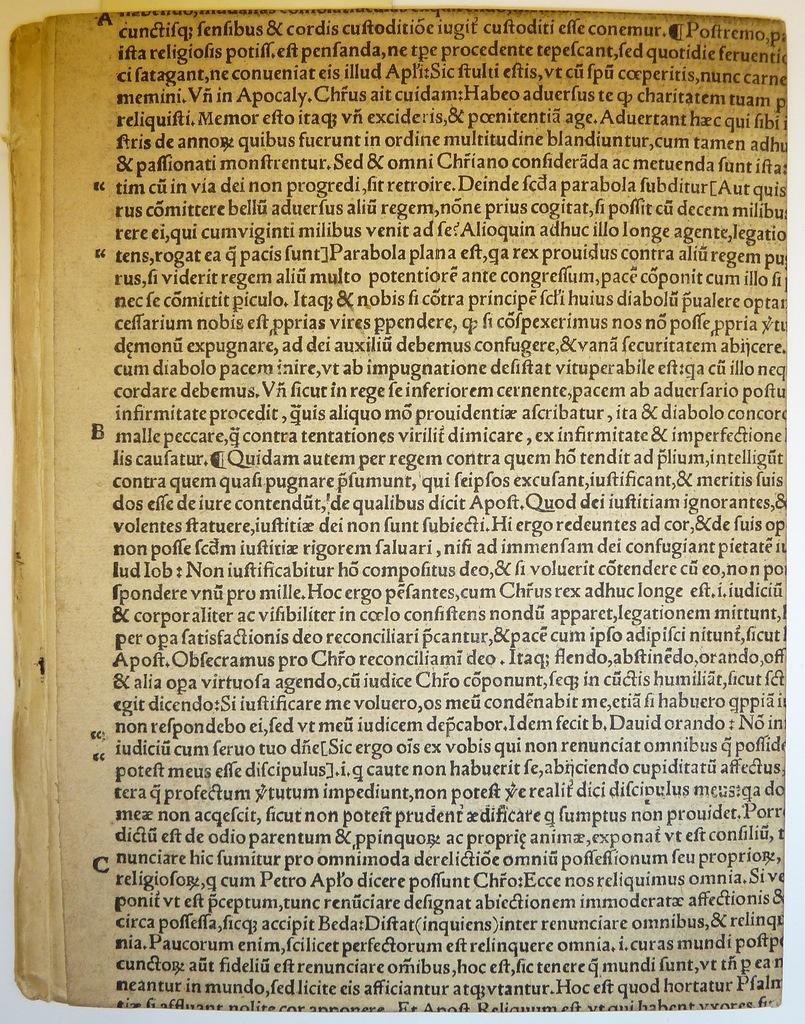What is the middle letter in the left margin?
Your response must be concise. B. 